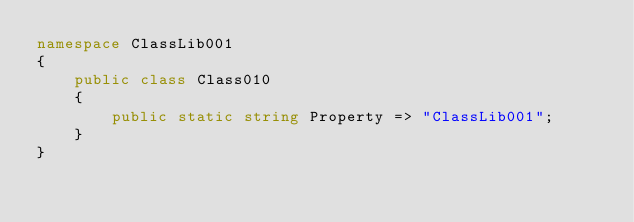Convert code to text. <code><loc_0><loc_0><loc_500><loc_500><_C#_>namespace ClassLib001
{
    public class Class010
    {
        public static string Property => "ClassLib001";
    }
}
</code> 